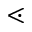<formula> <loc_0><loc_0><loc_500><loc_500>\leq s s d o t</formula> 